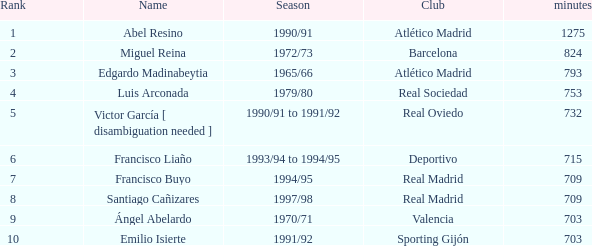What are the playing minutes of the real madrid player with a rank of 7 or higher? 709.0. 